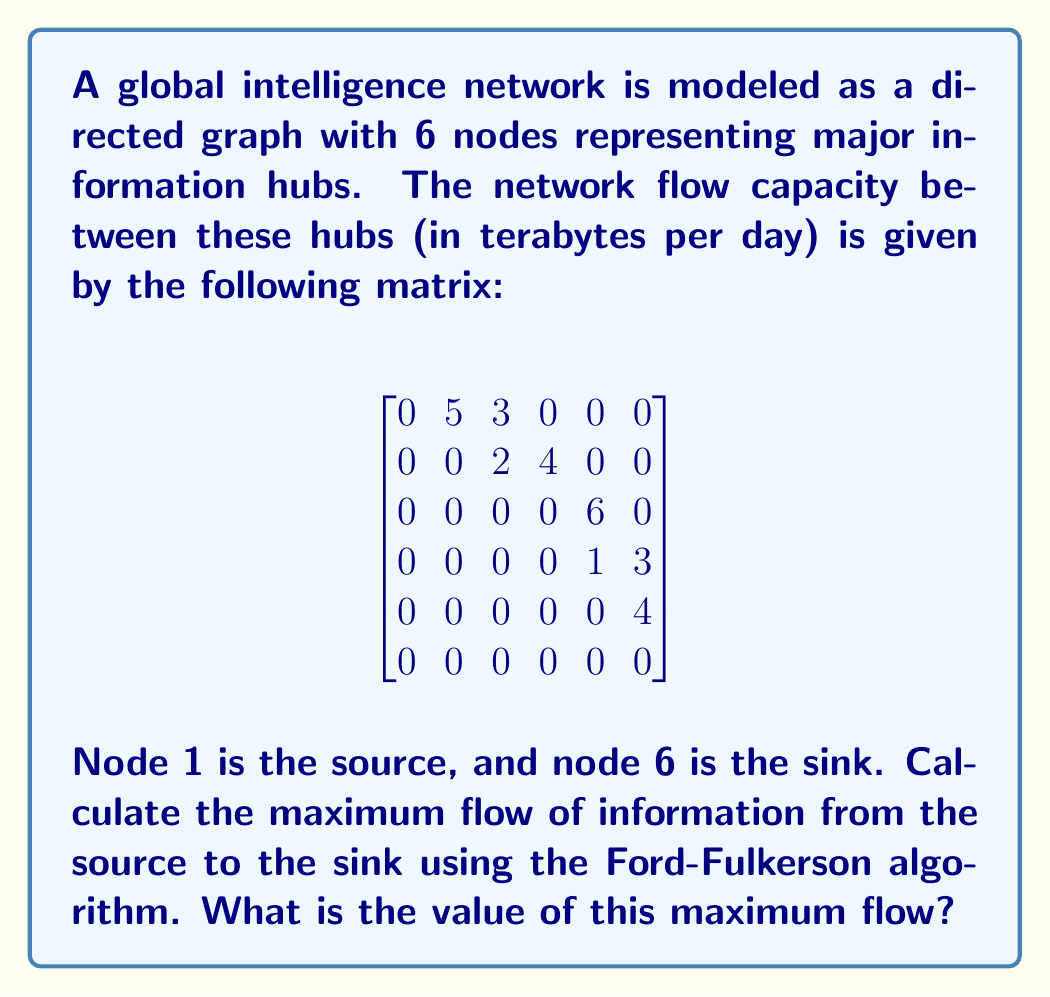Give your solution to this math problem. To solve this problem, we'll use the Ford-Fulkerson algorithm to find the maximum flow in the network. Here's a step-by-step explanation:

1) First, let's visualize the network:

[asy]
import graph;

size(200);

void drawNode(pair p, string s) {
  fill(circle(p, 0.3), white);
  draw(circle(p, 0.3));
  label(s, p);
}

pair[] nodes = {(0,0), (2,2), (2,-2), (4,2), (4,-2), (6,0)};
string[] labels = {"1", "2", "3", "4", "5", "6"};

for(int i = 0; i < 6; ++i) {
  drawNode(nodes[i], labels[i]);
}

draw(nodes[0]--nodes[1], arrow=Arrow(), L="5");
draw(nodes[0]--nodes[2], arrow=Arrow(), L="3");
draw(nodes[1]--nodes[2], arrow=Arrow(), L="2");
draw(nodes[1]--nodes[3], arrow=Arrow(), L="4");
draw(nodes[2]--nodes[4], arrow=Arrow(), L="6");
draw(nodes[3]--nodes[4], arrow=Arrow(), L="1");
draw(nodes[3]--nodes[5], arrow=Arrow(), L="3");
draw(nodes[4]--nodes[5], arrow=Arrow(), L="4");
[/asy]

2) Now, let's apply the Ford-Fulkerson algorithm:

   a) Find an augmenting path from source to sink. One possible path is 1 -> 2 -> 4 -> 6 with a flow of 3.
   b) Update the residual graph:
      $$
      \begin{bmatrix}
      0 & 2 & 3 & 0 & 0 & 0 \\
      0 & 0 & 2 & 1 & 0 & 0 \\
      0 & 0 & 0 & 0 & 6 & 0 \\
      0 & 0 & 0 & 0 & 1 & 0 \\
      0 & 0 & 0 & 0 & 0 & 4 \\
      0 & 0 & 0 & 0 & 0 & 0
      \end{bmatrix}
      $$

   c) Find another augmenting path: 1 -> 3 -> 5 -> 6 with a flow of 3.
   d) Update the residual graph:
      $$
      \begin{bmatrix}
      0 & 2 & 0 & 0 & 0 & 0 \\
      0 & 0 & 2 & 1 & 0 & 0 \\
      0 & 0 & 0 & 0 & 3 & 0 \\
      0 & 0 & 0 & 0 & 1 & 0 \\
      0 & 0 & 0 & 0 & 0 & 1 \\
      0 & 0 & 0 & 0 & 0 & 0
      \end{bmatrix}
      $$

   e) Find another augmenting path: 1 -> 2 -> 4 -> 5 -> 6 with a flow of 1.
   f) Update the residual graph:
      $$
      \begin{bmatrix}
      0 & 1 & 0 & 0 & 0 & 0 \\
      0 & 0 & 2 & 0 & 0 & 0 \\
      0 & 0 & 0 & 0 & 3 & 0 \\
      0 & 0 & 0 & 0 & 0 & 0 \\
      0 & 0 & 0 & 0 & 0 & 0 \\
      0 & 0 & 0 & 0 & 0 & 0
      \end{bmatrix}
      $$

3) No more augmenting paths can be found. The algorithm terminates.

4) The maximum flow is the sum of all flows we've pushed through the network:
   3 + 3 + 1 = 7 terabytes per day.
Answer: The maximum flow of information from the source to the sink is 7 terabytes per day. 